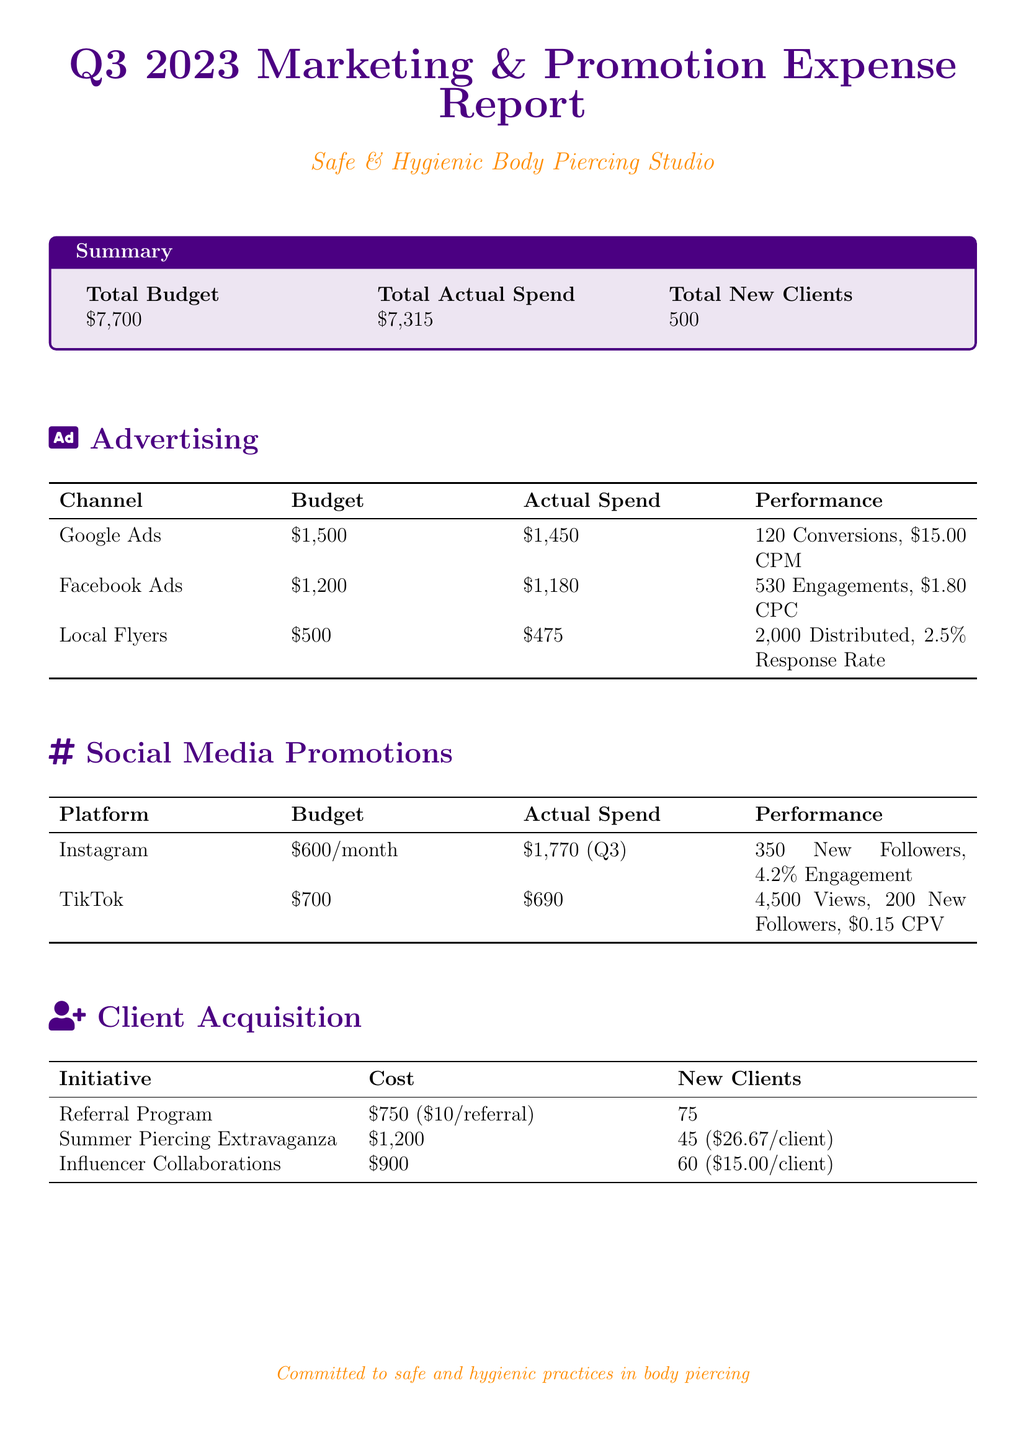What is the total budget? The total budget is outlined in the summary section of the document.
Answer: $7,700 What is the actual spend on Google Ads? The actual spend on Google Ads is detailed in the Advertising section.
Answer: $1,450 How many new clients were acquired through the Referral Program? The number of new clients from the Referral Program is specified in the Client Acquisition section.
Answer: 75 What was the performance of the Facebook Ads? The performance of Facebook Ads, including engagement and cost metrics, is listed in the Advertising section.
Answer: 530 Engagements, $1.80 CPC What is the total actual spend for Q3 2023? The total actual spend is provided in the summary section of the document.
Answer: $7,315 How much was spent on Instagram promotions for Q3? The actual spend on Instagram promotions for Q3 is indicated in the Social Media Promotions section.
Answer: $1,770 What was the response rate for Local Flyers? The response rate for Local Flyers is found under the Advertising section's performance metrics.
Answer: 2.5% What was the cost per new client for the Summer Piercing Extravaganza? The cost per new client for this initiative is calculated based on the total cost and new clients listed in the Client Acquisition section.
Answer: $26.67/client How many views did the TikTok promotions receive? The views for TikTok promotions are specified under Social Media Promotions.
Answer: 4,500 Views 